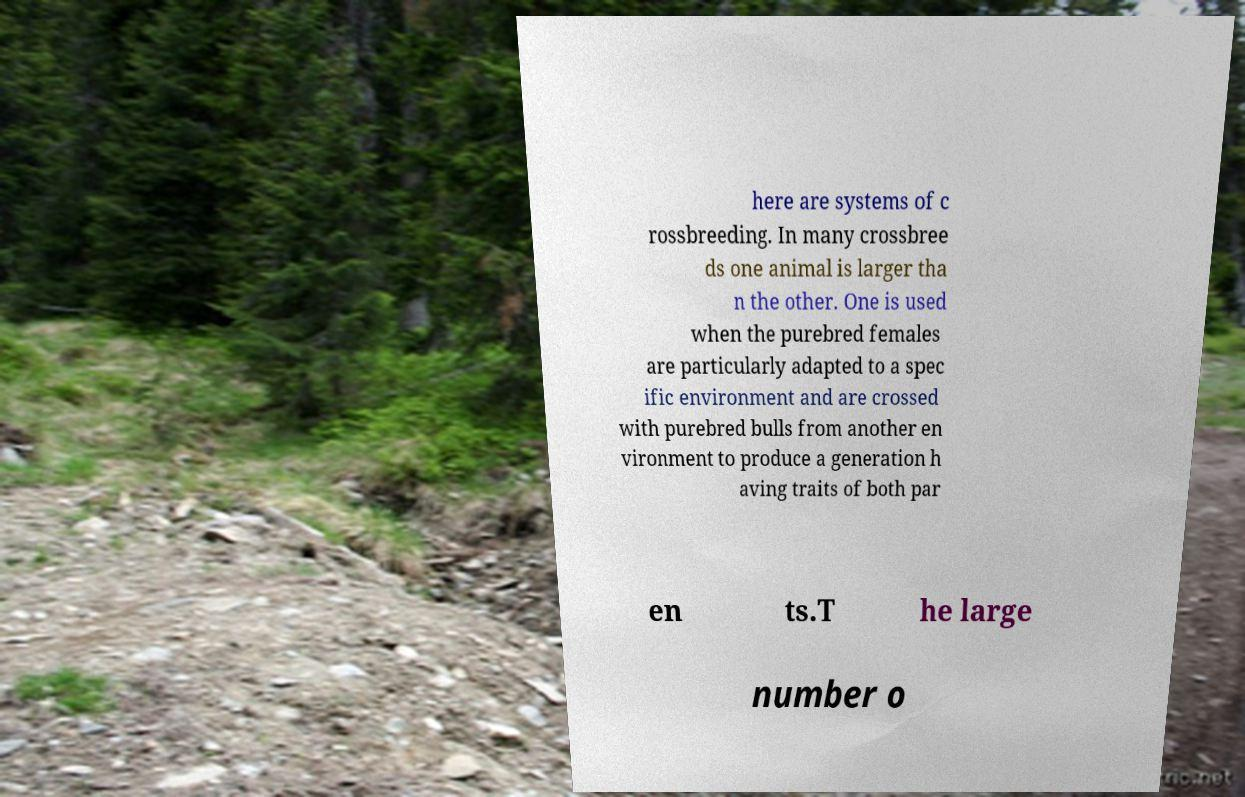Please identify and transcribe the text found in this image. here are systems of c rossbreeding. In many crossbree ds one animal is larger tha n the other. One is used when the purebred females are particularly adapted to a spec ific environment and are crossed with purebred bulls from another en vironment to produce a generation h aving traits of both par en ts.T he large number o 